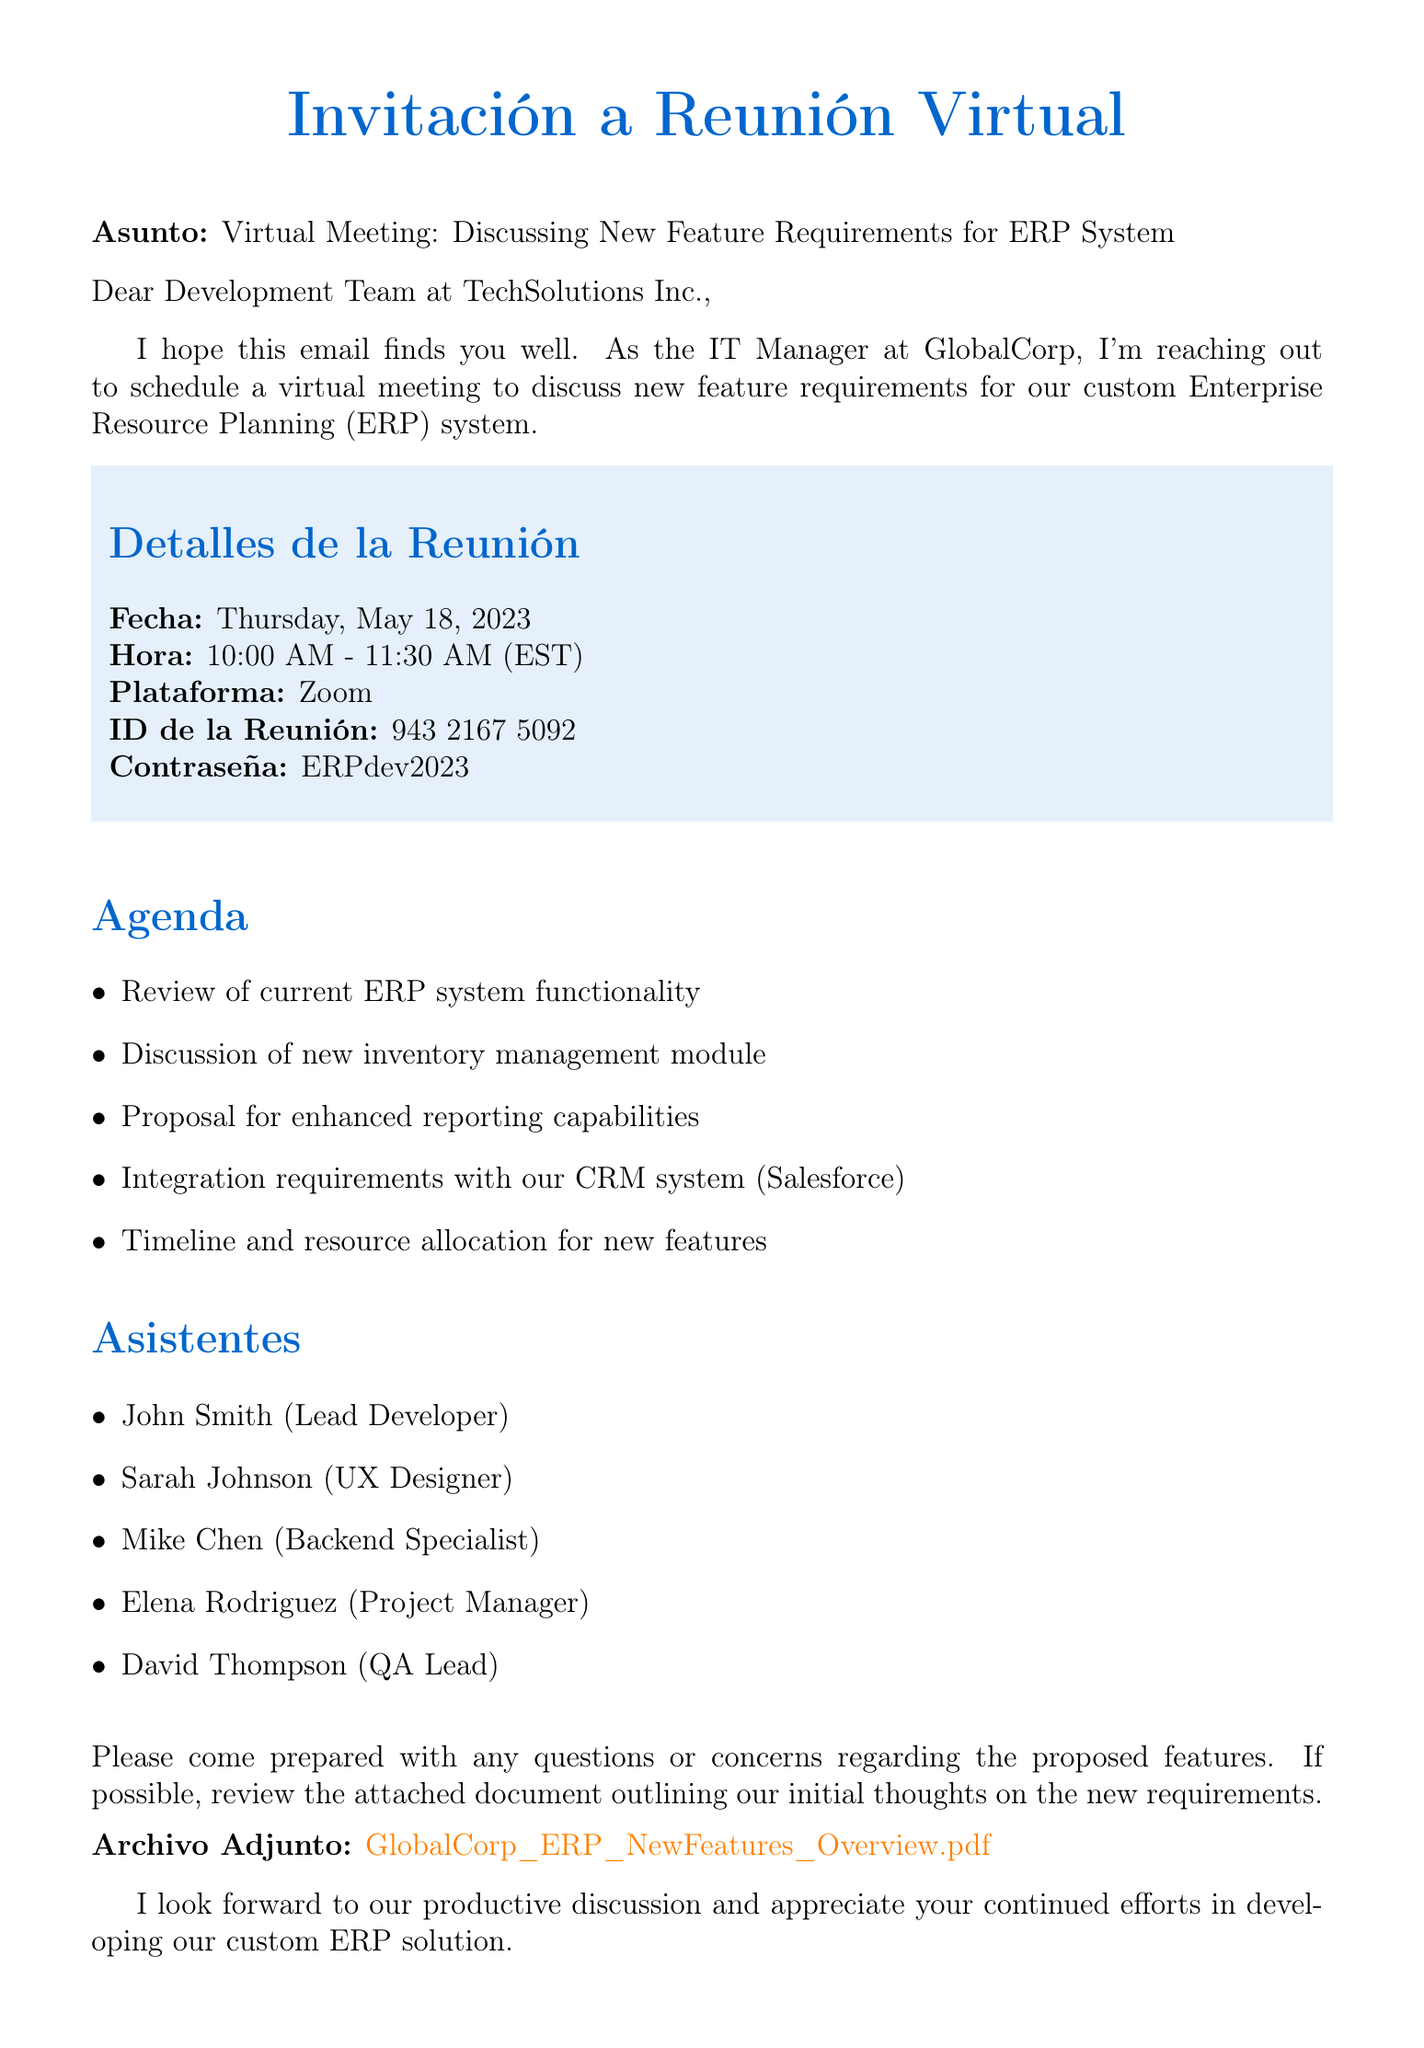What is the subject of the email? The subject of the email is stated at the beginning of the document, indicating the purpose of the communication.
Answer: Virtual Meeting: Discussing New Feature Requirements for ERP System What is the date of the meeting? The date of the meeting is specifically mentioned in the meeting details section.
Answer: Thursday, May 18, 2023 Who is the sender of the email? The sender's name and title are provided at the end of the document, indicating who is organizing the meeting.
Answer: Carlos Mendoza What platform will be used for the meeting? The meeting platform is mentioned in the details, defining how the meeting will be conducted.
Answer: Zoom What is one of the agenda items? The agenda items are listed explicitly, and only one needs to be provided as an example.
Answer: Discussion of new inventory management module Who is the Project Manager attending the meeting? The attendees list includes the roles and names of people who will join, indicating who the Project Manager is.
Answer: Elena Rodriguez What is the passcode for the meeting? The passcode is specifically mentioned as part of the meeting details for access.
Answer: ERPdev2023 What should attendees review before the meeting? This request is detailed towards the end of the document, indicating preparation for the meeting.
Answer: The attached document outlining our initial thoughts on the new requirements 